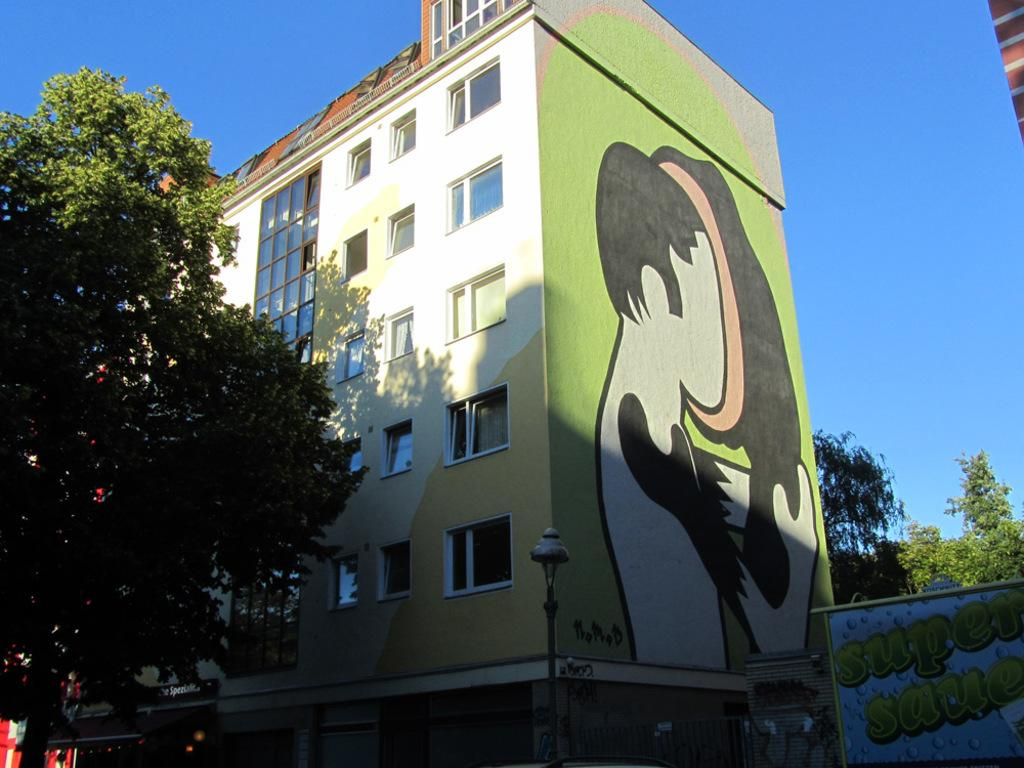What type of structure can be seen in the image? There is a light pole in the image. What else is present in the image besides the light pole? There is a board, objects, trees, a building with windows, and a painting on the wall in the image. Can you describe the building in the image? The building has windows and is located near other objects in the image. What is visible in the background of the image? The sky is visible in the background of the image. What type of education is being discussed in the image? There is no discussion or indication of education in the image. Is coal being used as a source of energy in the image? There is no mention or presence of coal in the image. 